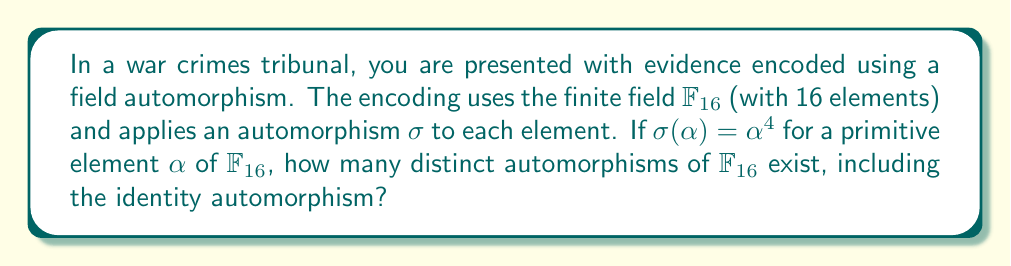Teach me how to tackle this problem. To solve this problem, let's follow these steps:

1) First, recall that $\mathbb{F}_{16}$ is an extension of $\mathbb{F}_2$ of degree 4, as $16 = 2^4$.

2) The automorphisms of a finite field $\mathbb{F}_{p^n}$ form a cyclic group of order $n$, generated by the Frobenius automorphism $x \mapsto x^p$.

3) In this case, $p = 2$ and $n = 4$, so the Frobenius automorphism is $x \mapsto x^2$.

4) The given automorphism $\sigma(\alpha) = \alpha^4$ is actually the square of the Frobenius automorphism, as $(\alpha^2)^2 = \alpha^4$.

5) The distinct automorphisms of $\mathbb{F}_{16}$ are:
   - Identity: $x \mapsto x$
   - Frobenius: $x \mapsto x^2$
   - Square of Frobenius: $x \mapsto x^4$
   - Cube of Frobenius: $x \mapsto x^8$

6) These four automorphisms correspond to the four elements of the Galois group $\text{Gal}(\mathbb{F}_{16}/\mathbb{F}_2)$.

Therefore, there are 4 distinct automorphisms of $\mathbb{F}_{16}$, including the identity automorphism.
Answer: 4 